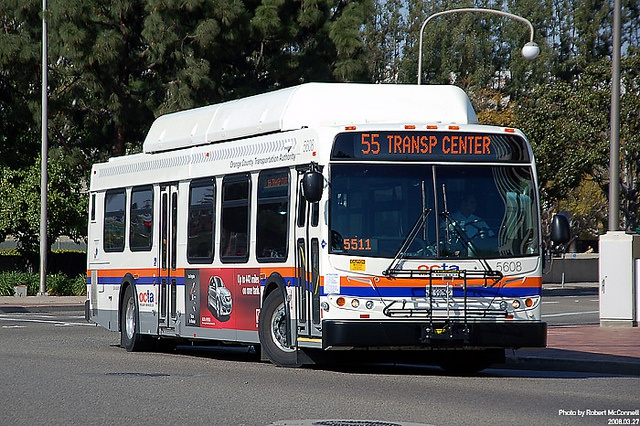Describe the objects in this image and their specific colors. I can see bus in black, white, navy, and gray tones and people in black, darkblue, blue, and teal tones in this image. 